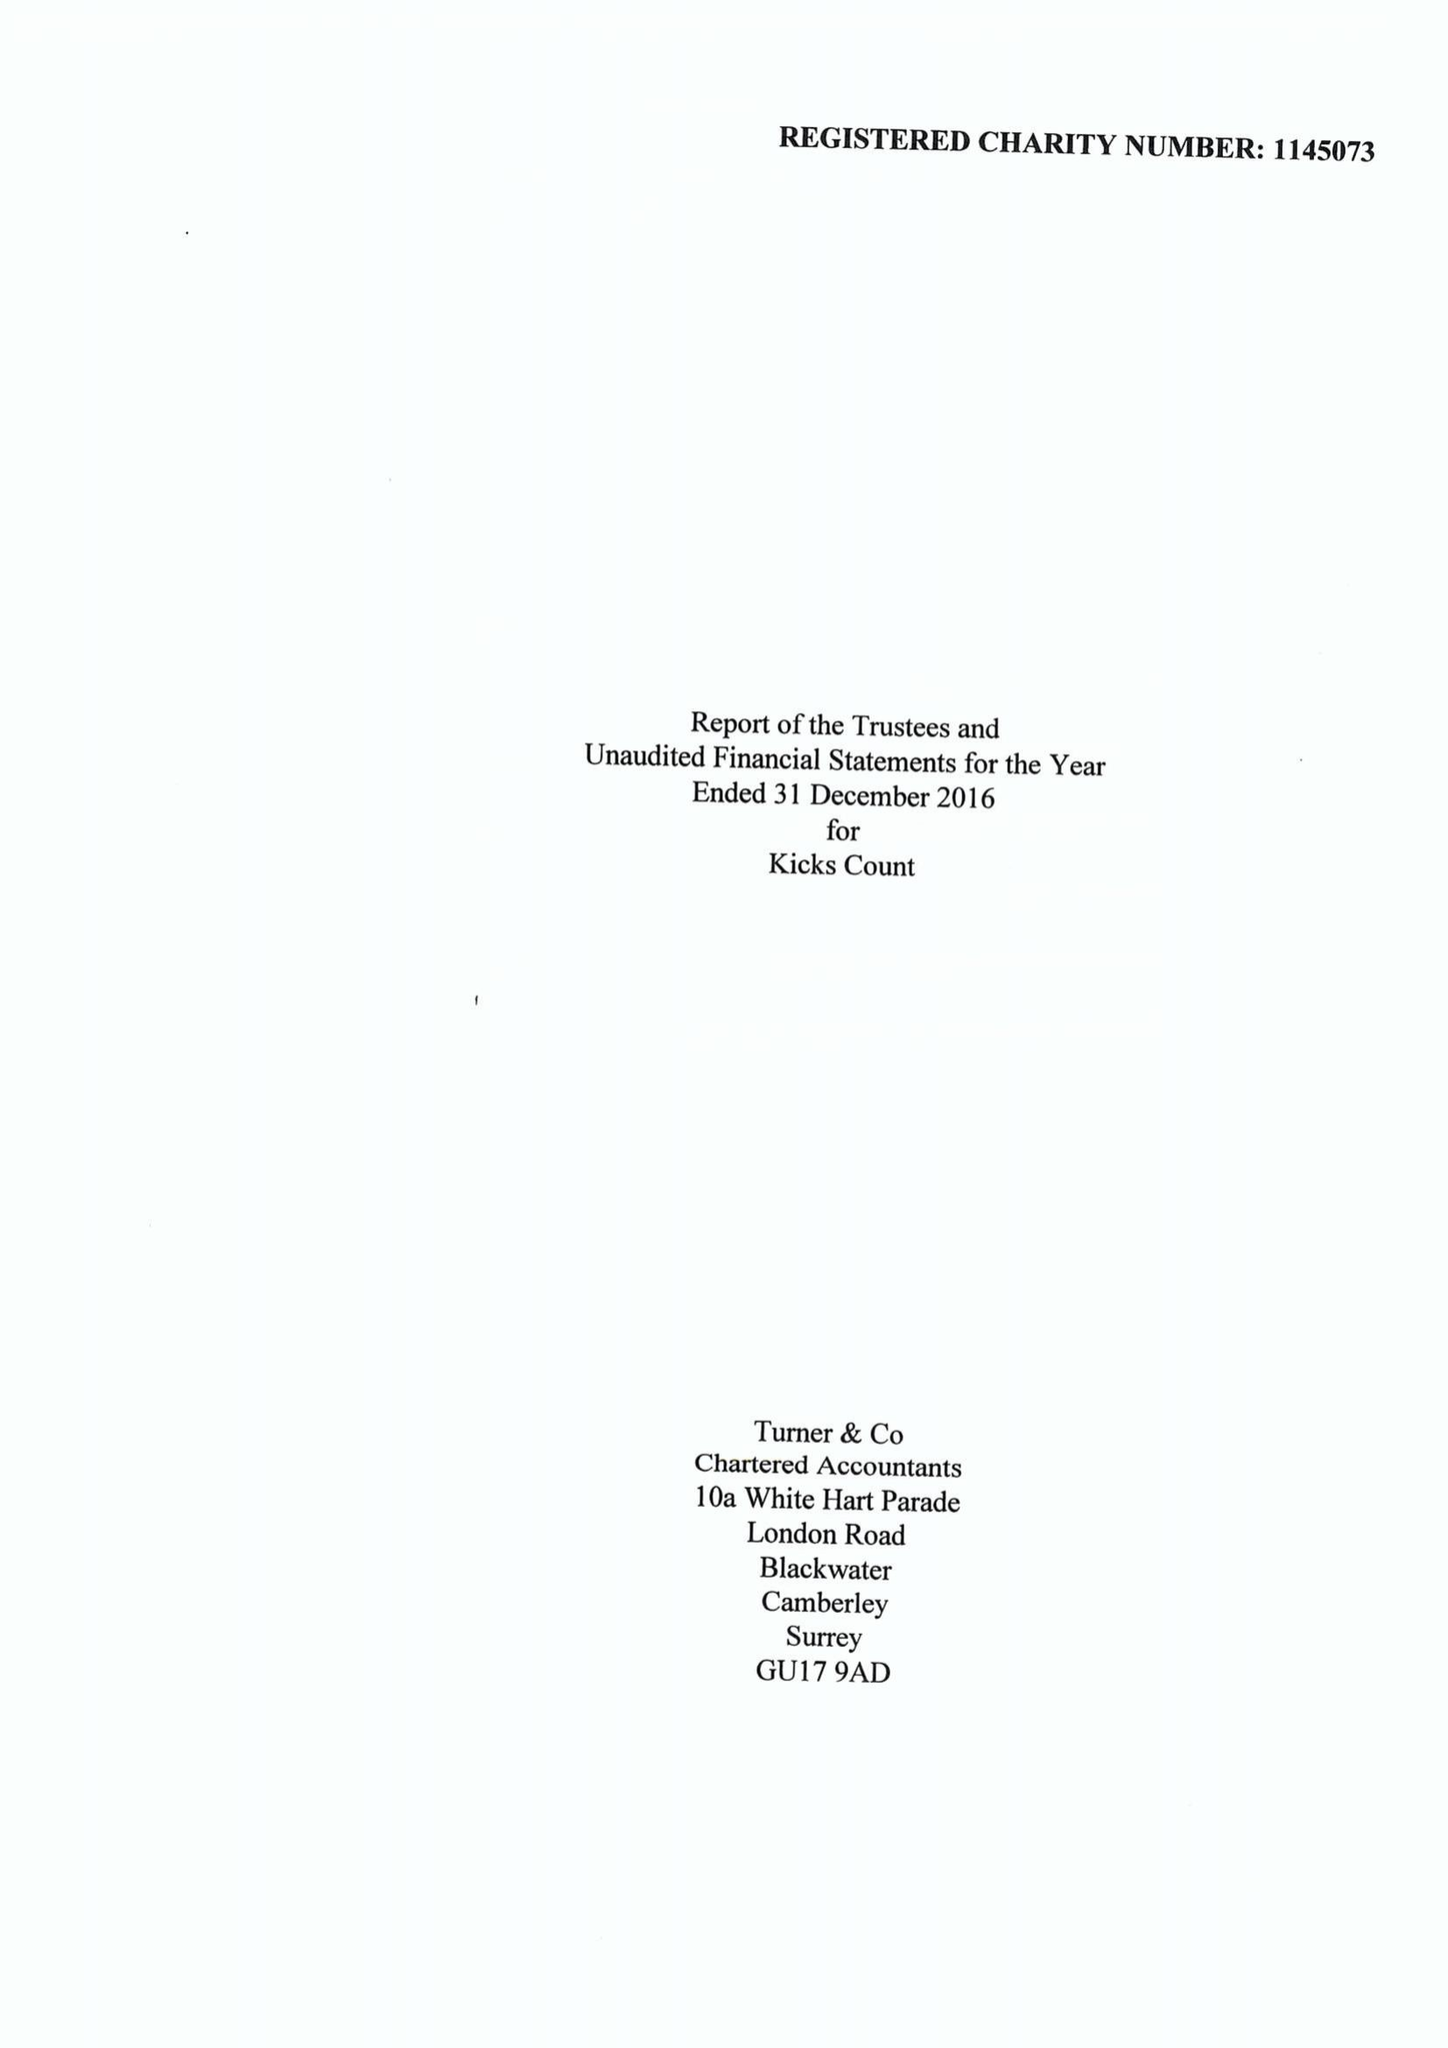What is the value for the report_date?
Answer the question using a single word or phrase. 2016-12-31 